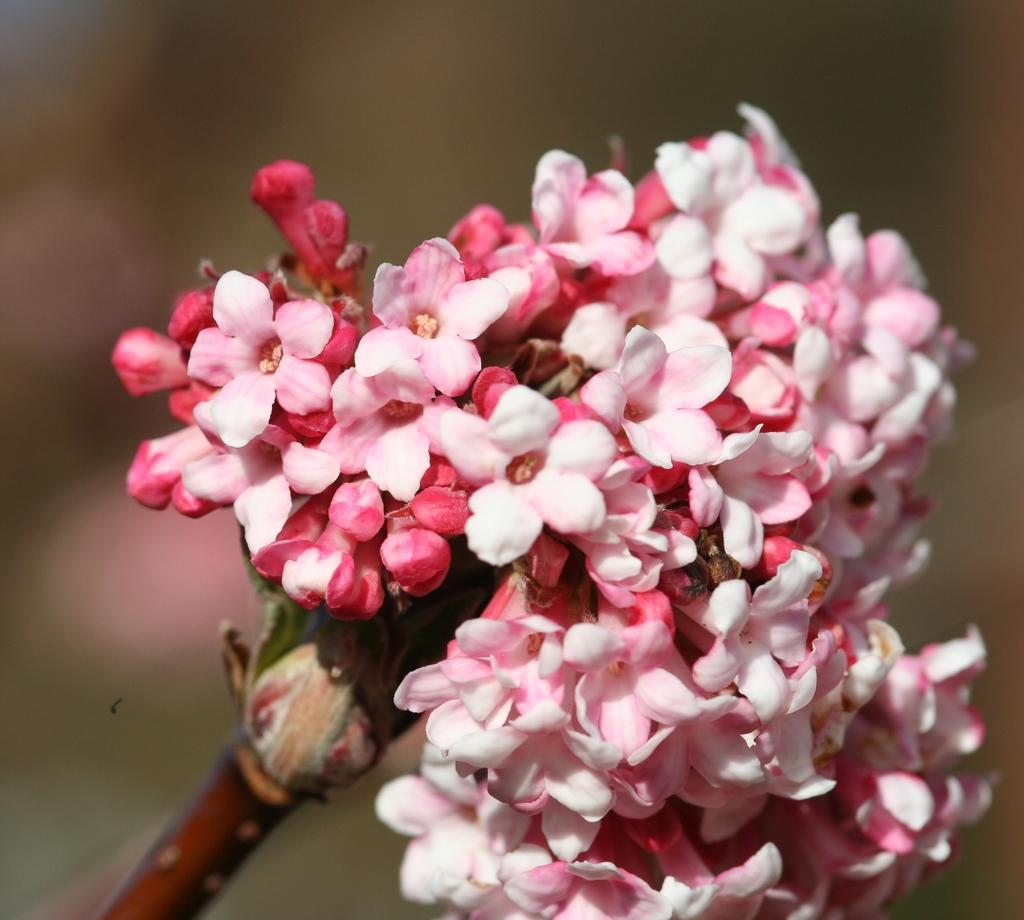What type of living organisms can be seen in the image? There are flowers in the image. Can you describe the background of the image? The background of the image is blurred. How many zippers can be seen on the flowers in the image? There are no zippers present on the flowers in the image. What type of fruit is being used to decorate the flowers in the image? There are no fruits, including oranges, present in the image. 